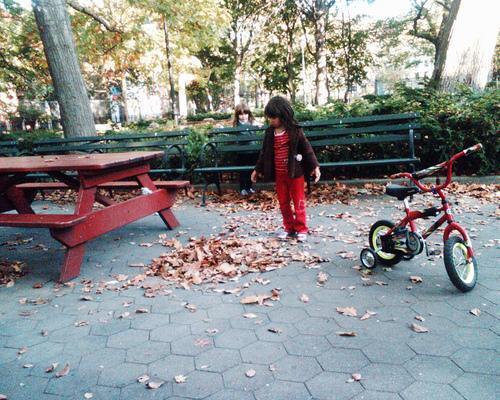How many girls are visible?
Give a very brief answer. 2. How many benches are there?
Give a very brief answer. 3. How many trains are there?
Give a very brief answer. 0. 